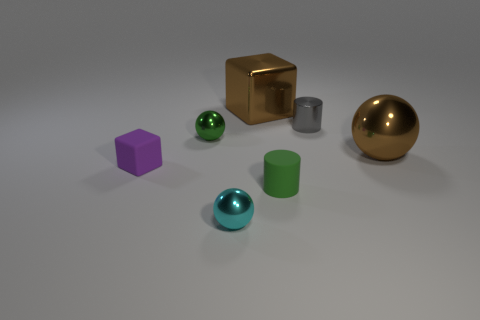What is the shape of the tiny green rubber thing?
Offer a terse response. Cylinder. There is a cylinder in front of the small block; is it the same size as the brown thing in front of the large shiny cube?
Keep it short and to the point. No. What is the size of the brown shiny object behind the metal sphere that is to the right of the small cylinder that is behind the green cylinder?
Ensure brevity in your answer.  Large. The small green object that is in front of the green thing on the left side of the small green thing that is to the right of the small cyan object is what shape?
Ensure brevity in your answer.  Cylinder. There is a large thing that is left of the small gray shiny cylinder; what shape is it?
Offer a terse response. Cube. Do the tiny green sphere and the cube that is behind the big metal ball have the same material?
Make the answer very short. Yes. How many other things are there of the same shape as the small gray shiny object?
Make the answer very short. 1. Is the color of the tiny cube the same as the large metal object that is in front of the large metallic block?
Provide a succinct answer. No. Are there any other things that are the same material as the big block?
Provide a short and direct response. Yes. The green object that is behind the small purple cube left of the small gray shiny object is what shape?
Offer a terse response. Sphere. 